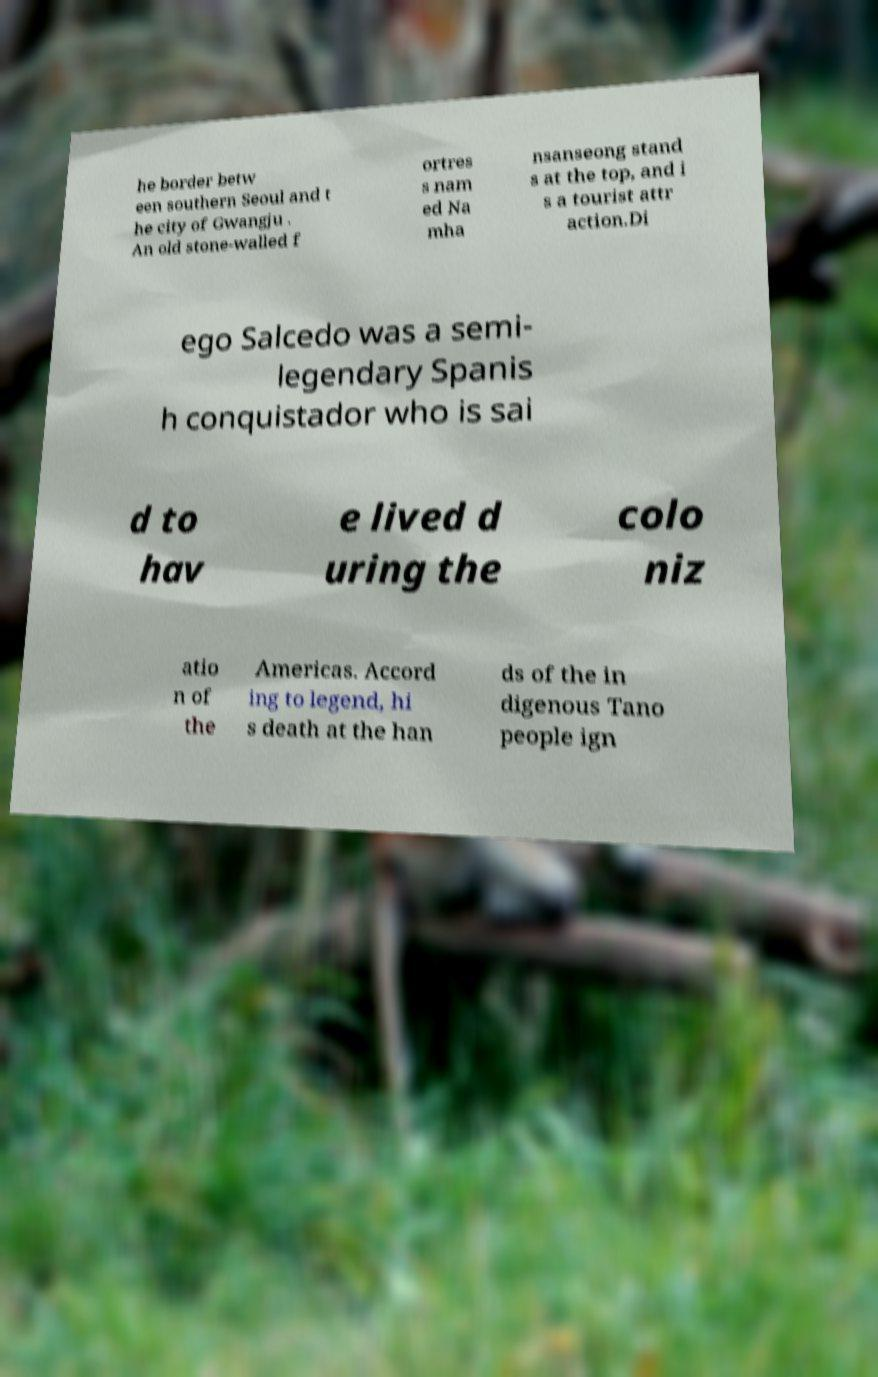Can you read and provide the text displayed in the image?This photo seems to have some interesting text. Can you extract and type it out for me? he border betw een southern Seoul and t he city of Gwangju . An old stone-walled f ortres s nam ed Na mha nsanseong stand s at the top, and i s a tourist attr action.Di ego Salcedo was a semi- legendary Spanis h conquistador who is sai d to hav e lived d uring the colo niz atio n of the Americas. Accord ing to legend, hi s death at the han ds of the in digenous Tano people ign 